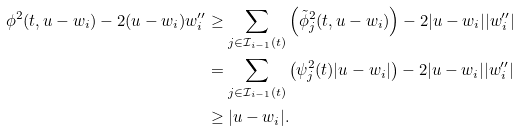Convert formula to latex. <formula><loc_0><loc_0><loc_500><loc_500>\phi ^ { 2 } ( t , u - w _ { i } ) - 2 ( u - w _ { i } ) w _ { i } ^ { \prime \prime } & \geq \sum _ { j \in \mathcal { I } _ { i - 1 } ( t ) } \left ( \tilde { \phi } _ { j } ^ { 2 } ( t , u - w _ { i } ) \right ) - 2 | u - w _ { i } | | w _ { i } ^ { \prime \prime } | \\ & = \sum _ { j \in \mathcal { I } _ { i - 1 } ( t ) } \left ( \psi _ { j } ^ { 2 } ( t ) | u - w _ { i } | \right ) - 2 | u - w _ { i } | | w _ { i } ^ { \prime \prime } | \\ & \geq | u - w _ { i } | .</formula> 